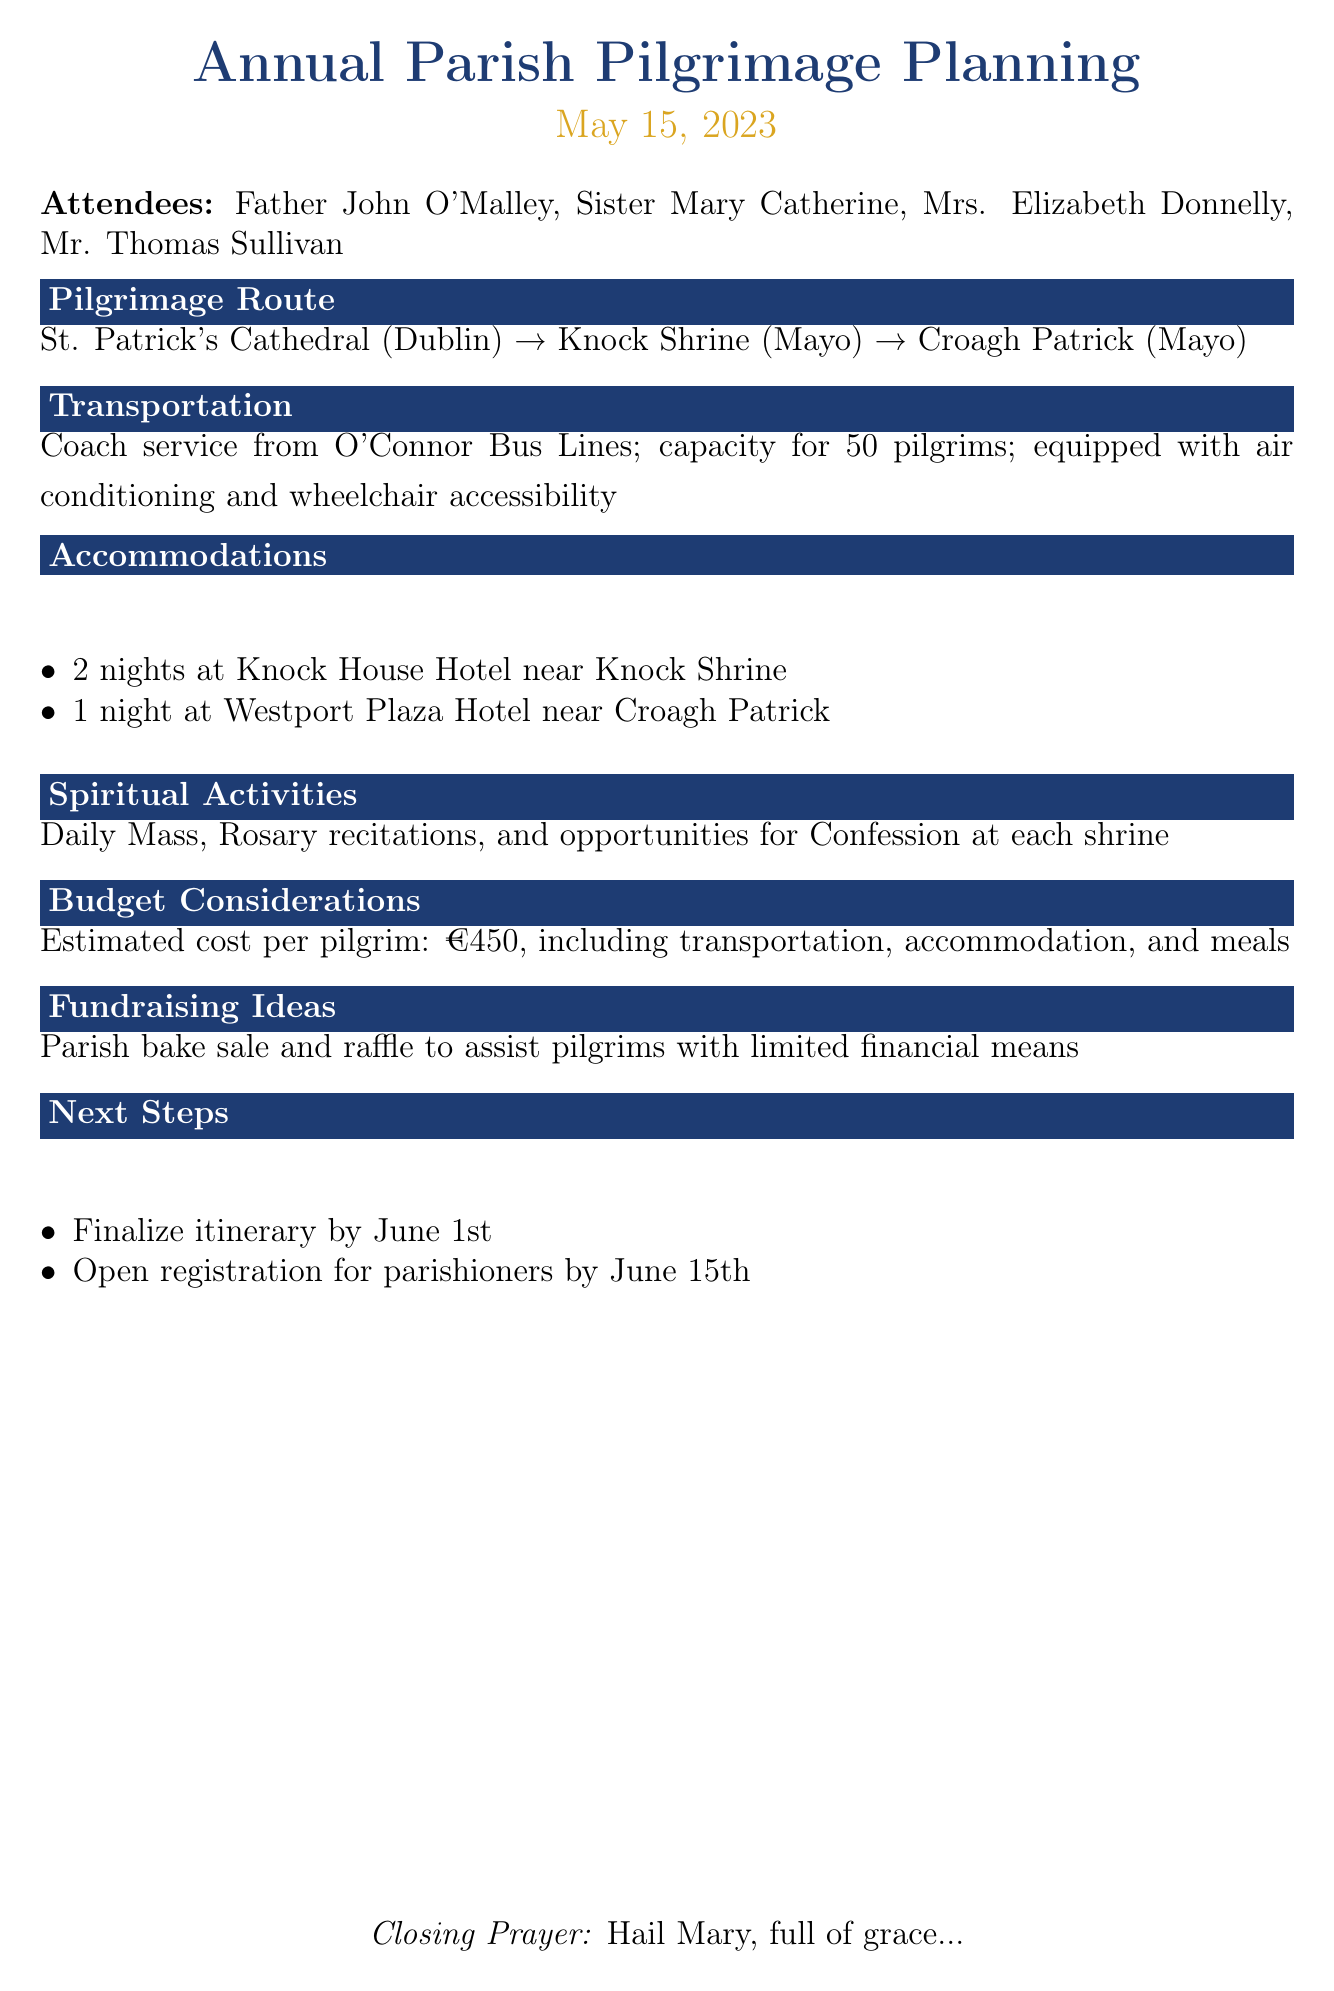What is the title of the meeting? The title of the meeting is the main heading in the document, which appears at the top.
Answer: Annual Parish Pilgrimage Planning Who are the attendees? The attendees are listed in a sentence at the beginning of the document.
Answer: Father John O'Malley, Sister Mary Catherine, Mrs. Elizabeth Donnelly, Mr. Thomas Sullivan What is the estimated cost per pilgrim? The estimated cost is mentioned under the budget considerations section.
Answer: €450 How many nights will the group stay at Knock House Hotel? The number of nights at Knock House Hotel is specified in the accommodations section.
Answer: 2 nights What is the transportation company used for the pilgrimage? The transportation company is mentioned in the transportation section of the document.
Answer: O'Connor Bus Lines What spiritual activities will be included in the pilgrimage? The spiritual activities are listed in the dedicated section of the document.
Answer: Daily Mass, Rosary recitations, and opportunities for Confession When is the registration opening for parishioners? The registration opening date is indicated in the next steps section of the document.
Answer: June 15th What is the proposed route of the pilgrimage? The proposed route is stated in the first agenda item's details.
Answer: St. Patrick's Cathedral (Dublin) → Knock Shrine (Mayo) → Croagh Patrick (Mayo) 